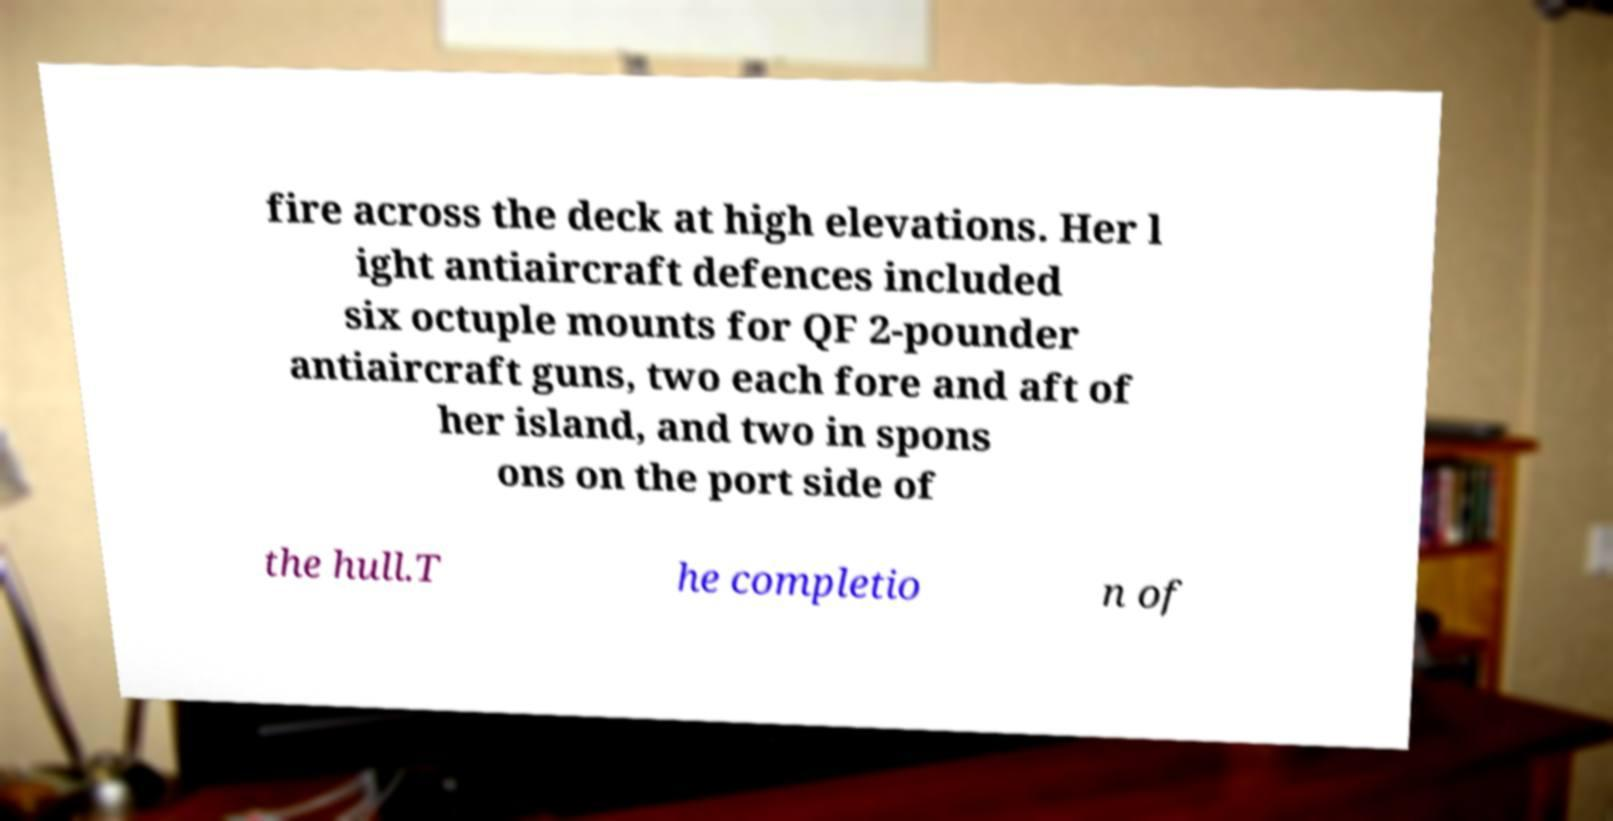What messages or text are displayed in this image? I need them in a readable, typed format. fire across the deck at high elevations. Her l ight antiaircraft defences included six octuple mounts for QF 2-pounder antiaircraft guns, two each fore and aft of her island, and two in spons ons on the port side of the hull.T he completio n of 